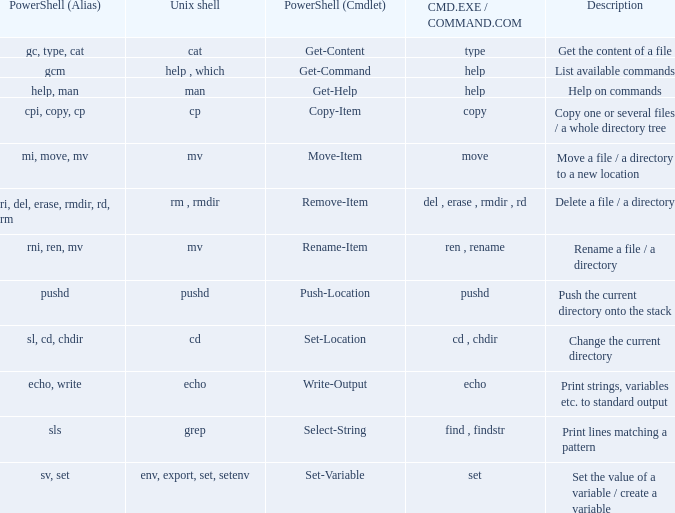What are all values of CMD.EXE / COMMAND.COM for the unix shell echo? Echo. 